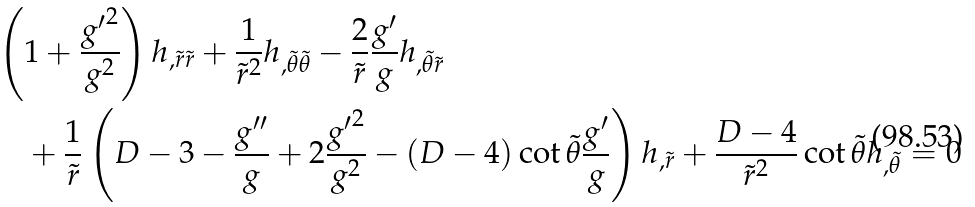Convert formula to latex. <formula><loc_0><loc_0><loc_500><loc_500>& \left ( 1 + \frac { { g ^ { \prime } } ^ { 2 } } { g ^ { 2 } } \right ) h _ { , \tilde { r } \tilde { r } } + \frac { 1 } { \tilde { r } ^ { 2 } } h _ { , \tilde { \theta } \tilde { \theta } } - \frac { 2 } { \tilde { r } } \frac { g ^ { \prime } } { g } h _ { , \tilde { \theta } \tilde { r } } \\ & \quad + \frac { 1 } { \tilde { r } } \left ( D - 3 - \frac { g ^ { \prime \prime } } { g } + 2 \frac { { g ^ { \prime } } ^ { 2 } } { g ^ { 2 } } - ( D - 4 ) \cot \tilde { \theta } \frac { g ^ { \prime } } { g } \right ) h _ { , \tilde { r } } + \frac { D - 4 } { \tilde { r } ^ { 2 } } \cot \tilde { \theta } h _ { , \tilde { \theta } } = 0</formula> 